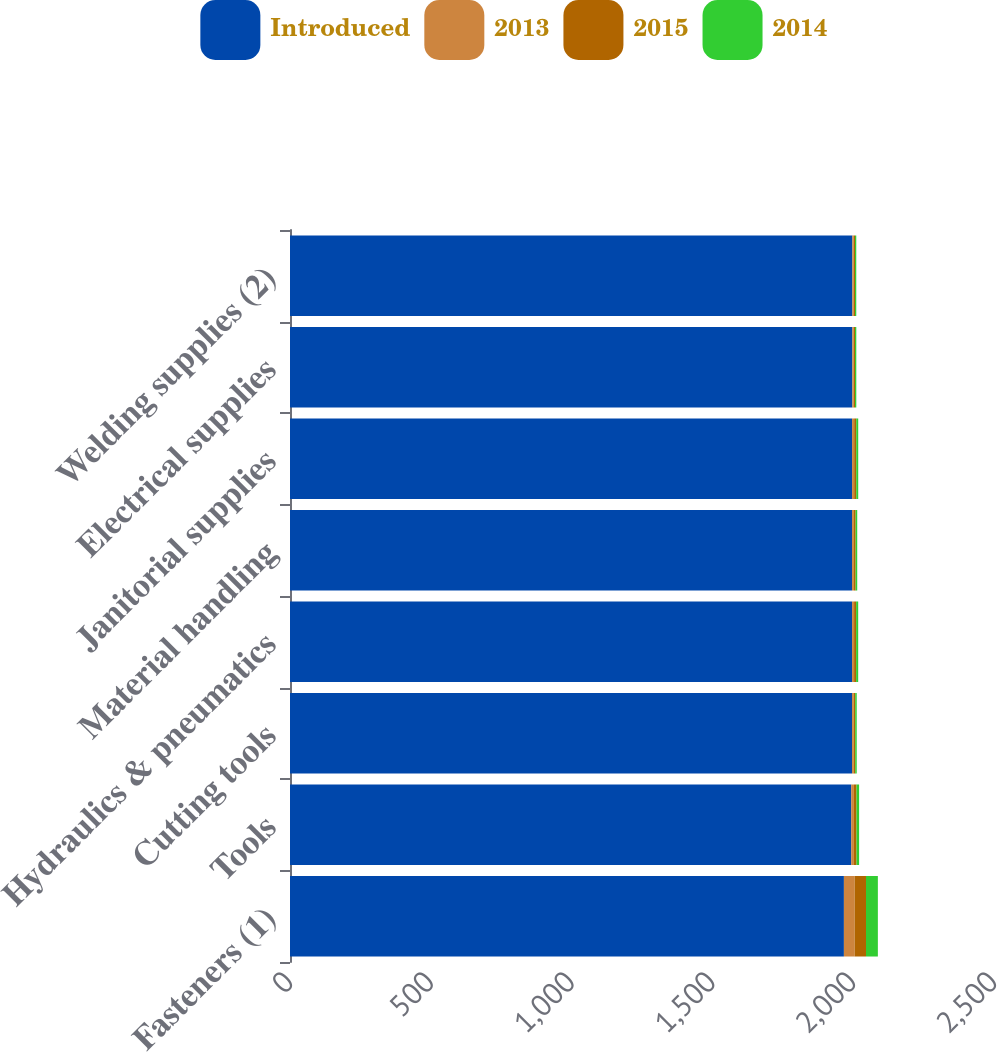<chart> <loc_0><loc_0><loc_500><loc_500><stacked_bar_chart><ecel><fcel>Fasteners (1)<fcel>Tools<fcel>Cutting tools<fcel>Hydraulics & pneumatics<fcel>Material handling<fcel>Janitorial supplies<fcel>Electrical supplies<fcel>Welding supplies (2)<nl><fcel>Introduced<fcel>1967<fcel>1993<fcel>1996<fcel>1996<fcel>1996<fcel>1996<fcel>1997<fcel>1997<nl><fcel>2013<fcel>38.3<fcel>9.5<fcel>5.6<fcel>7.2<fcel>6.5<fcel>7.5<fcel>4.7<fcel>4.7<nl><fcel>2015<fcel>40.2<fcel>9.3<fcel>5.5<fcel>7.2<fcel>6.1<fcel>7.3<fcel>4.7<fcel>4.7<nl><fcel>2014<fcel>42.1<fcel>9.2<fcel>5.4<fcel>7.3<fcel>5.7<fcel>7<fcel>4.6<fcel>4.5<nl></chart> 